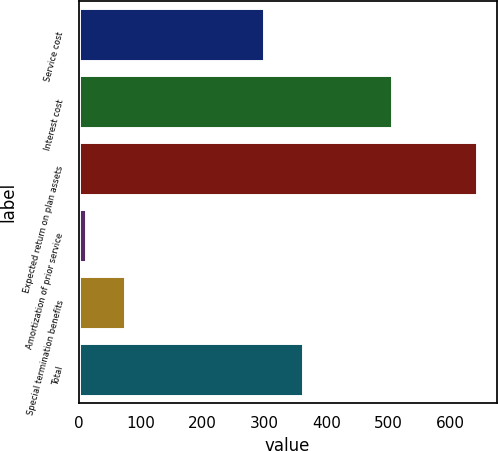<chart> <loc_0><loc_0><loc_500><loc_500><bar_chart><fcel>Service cost<fcel>Interest cost<fcel>Expected return on plan assets<fcel>Amortization of prior service<fcel>Special termination benefits<fcel>Total<nl><fcel>299<fcel>506<fcel>643<fcel>12<fcel>75.1<fcel>362.1<nl></chart> 